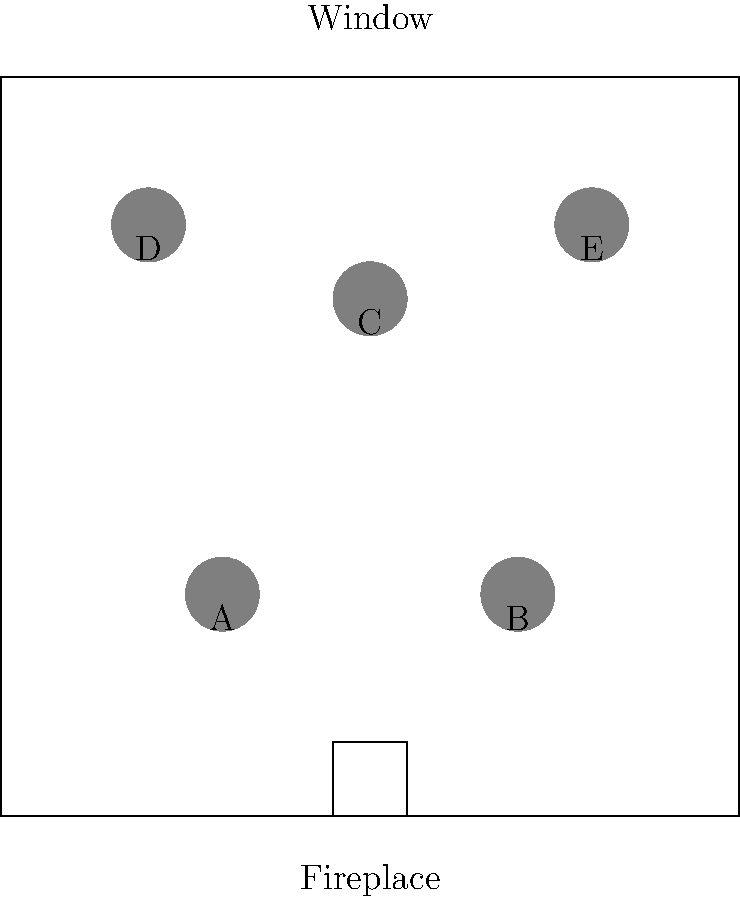In recreating an authentic Victorian-era parlor, which arrangement of furniture items (A, B, C, D, E) would be most historically accurate? Consider the typical layout principles of the period, including the importance of natural light and the central role of the fireplace. To determine the most historically accurate arrangement for a Victorian-era parlor, we need to consider the following principles:

1. Natural light: Victorian rooms emphasized natural light, so furniture was often arranged to take advantage of windows.

2. Fireplace focus: The fireplace was a central feature in Victorian rooms, serving as a focal point.

3. Symmetry: Victorian design often favored symmetrical arrangements.

4. Conversation areas: Furniture was arranged to facilitate intimate conversations.

5. Wall alignment: Larger pieces were typically placed against walls, leaving the center of the room open.

Analyzing the given layout:

- Items A and B are positioned symmetrically near the fireplace, likely representing larger pieces like armchairs or a settee.
- Item C is centrally located, possibly a center table.
- Items D and E are near the window, potentially smaller chairs or side tables.

The most historically accurate arrangement would be:

- A and B as main seating near the fireplace, creating a symmetrical focal point.
- C as a center table, anchoring the room and providing a surface for lamps or decorative items.
- D and E as additional seating or side tables near the window, taking advantage of natural light for reading or needlework.

This arrangement adheres to Victorian principles by emphasizing the fireplace, utilizing natural light, maintaining symmetry, and creating conversation areas.
Answer: A, B, C, D, E (in current positions) 